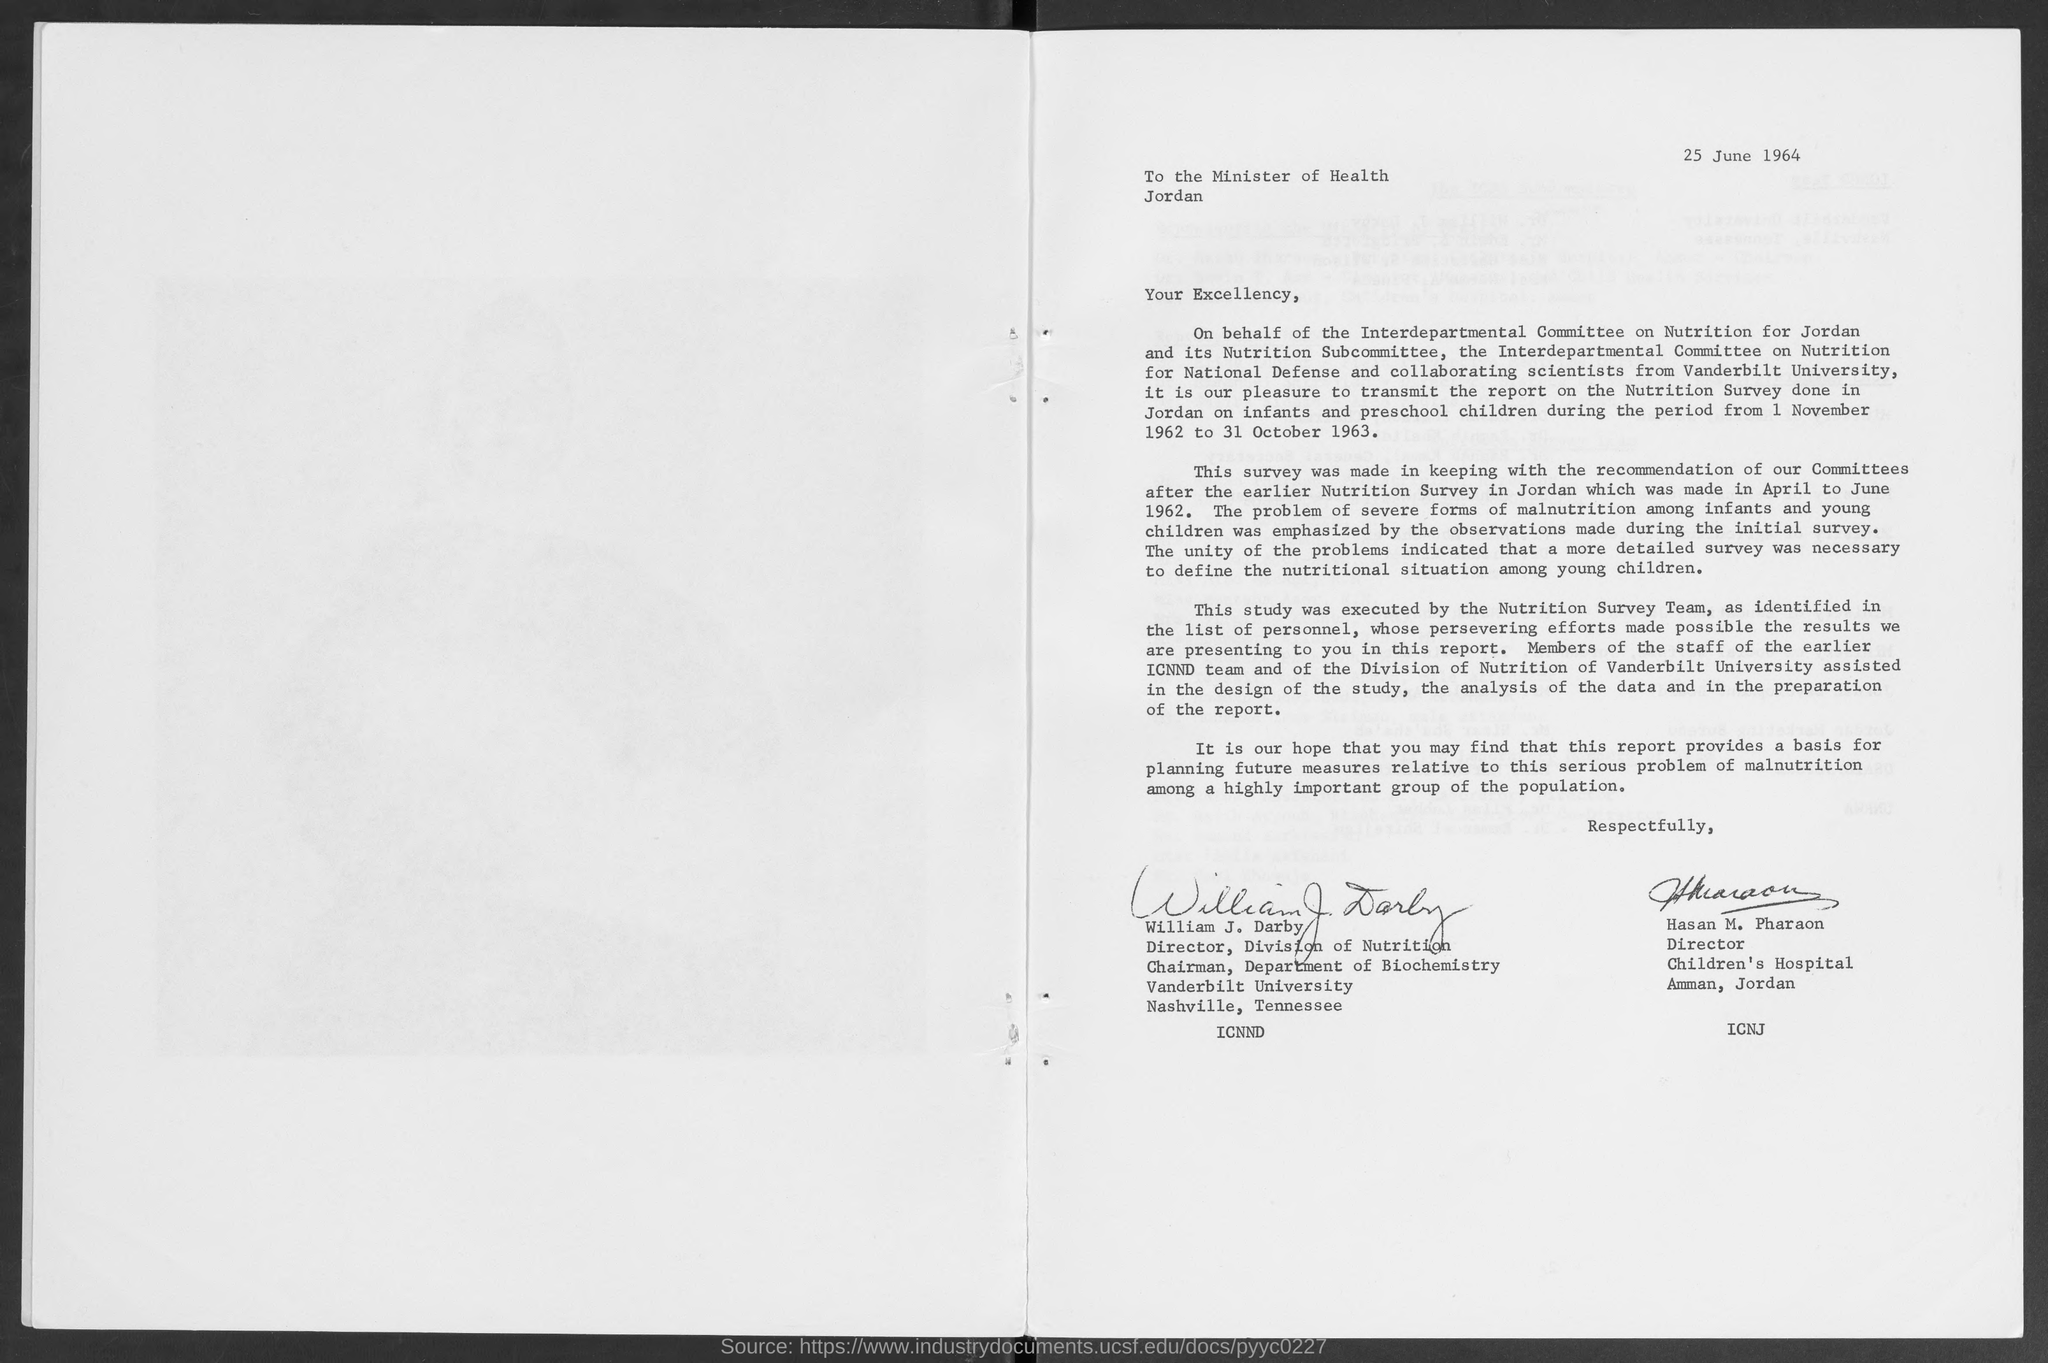Point out several critical features in this image. William J. Darby is the Director of the Division of Nutrition. The issued date of this letter is June 25, 1964. 